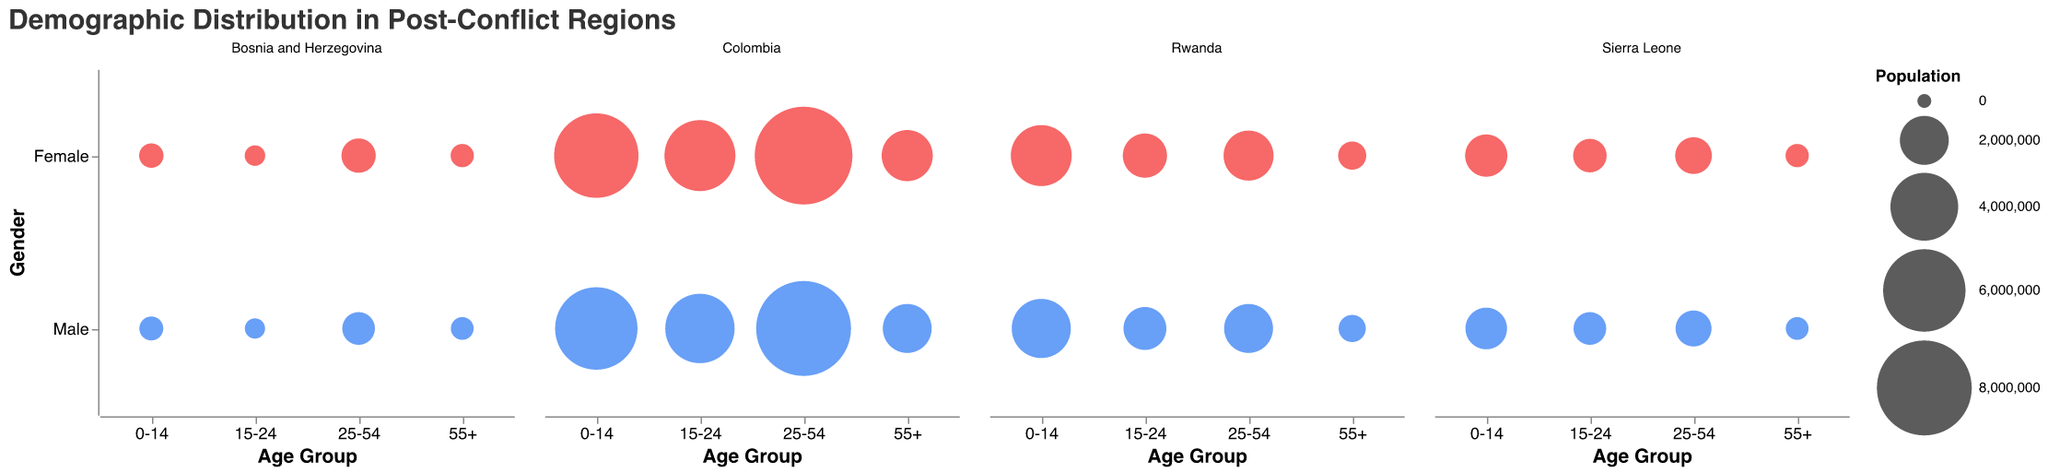What is the total population for the age group 0-14 in Colombia? First, identify the population of males (6,000,000) and females (6,300,000) in the 0-14 age group in Colombia. Then, sum these values: 6,000,000 + 6,300,000 = 12,300,000
Answer: 12,300,000 Which region has the largest population in the 25-54 age group? Compare the populations of the 25-54 age group across all regions: Rwanda (2,000,000 + 2,100,000 = 4,100,000), Bosnia and Herzegovina (800,000 + 900,000 = 1,700,000), Colombia (8,000,000 + 8,500,000 = 16,500,000), Sierra Leone (1,000,000 + 1,050,000 = 2,050,000). The largest population is in Colombia
Answer: Colombia In Bosnia and Herzegovina, which gender has a larger population in the age group 55+ and by how much? Compare the male (300,000) and female (320,000) populations in the 55+ age group in Bosnia and Herzegovina: 320,000 - 300,000 = 20,000. Females have a larger population
Answer: Females, 20,000 How does the population difference between genders in the 15-24 age group in Rwanda compare to Sierra Leone? Calculate the gender population difference for each region (Rwanda: 1,600,000 - 1,500,000 = 100,000; Sierra Leone: 850,000 - 800,000 = 50,000). Rwanda's difference is larger (100,000 vs 50,000)
Answer: Rwanda, 50,000 more Among the four regions, which has the smallest population in the 0-14 age group, and what is it? Identify and compare the populations in the 0-14 age group in each region (Rwanda: 6,200,000, Bosnia and Herzegovina: 720,000, Colombia: 12,300,000, Sierra Leone: 2,850,000). The smallest population is in Bosnia and Herzegovina
Answer: Bosnia and Herzegovina, 720,000 What is the average population of the 55+ age group across all regions? Sum the populations of the 55+ age group for all regions, then divide by the number of regions: Rwanda (500,000 + 550,000), Bosnia and Herzegovina (300,000 + 320,000), Colombia (2,000,000 + 2,200,000), Sierra Leone (300,000 + 320,000). Total is 6,490,000; average = 6,490,000 / 4 = 1,622,500
Answer: 1,622,500 Which region has the most equal gender distribution in the 25-54 age group, and what is the difference in population between genders? Calculate the difference for each region in the 25-54 age group (Rwanda: 2,100,000 - 2,000,000 = 100,000; Bosnia and Herzegovina: 900,000 - 800,000 = 100,000; Colombia: 8,500,000 - 8,000,000 = 500,000; Sierra Leone: 1,050,000 - 1,000,000 = 50,000). The smallest difference is in Sierra Leone
Answer: Sierra Leone, 50,000 How many regions have a larger female population in the 0-14 age group? Identify the gender populations in the 0-14 age group for each region and count those with more females: Rwanda (female larger), Bosnia and Herzegovina (female larger), Colombia (female larger), Sierra Leone (female larger). There are 4 regions
Answer: 4 regions 